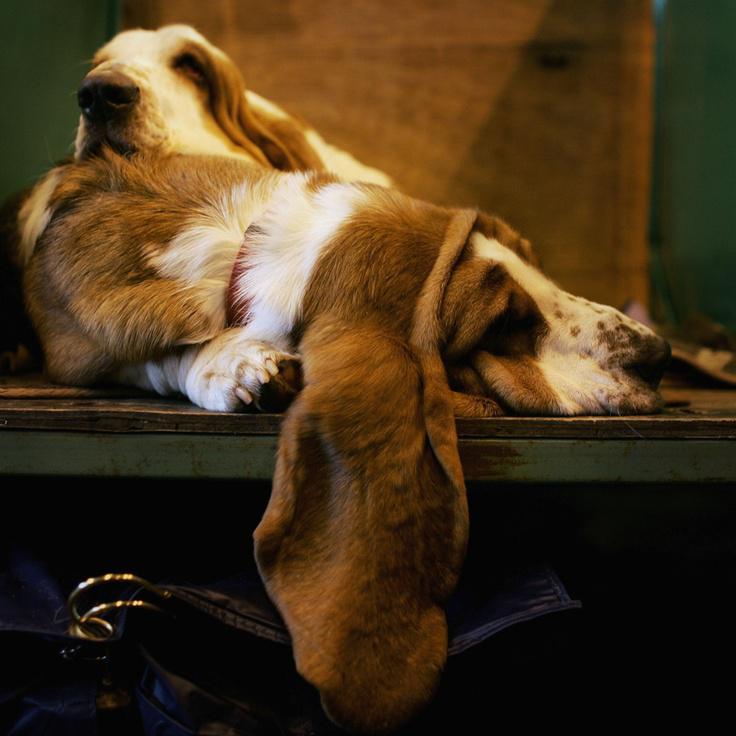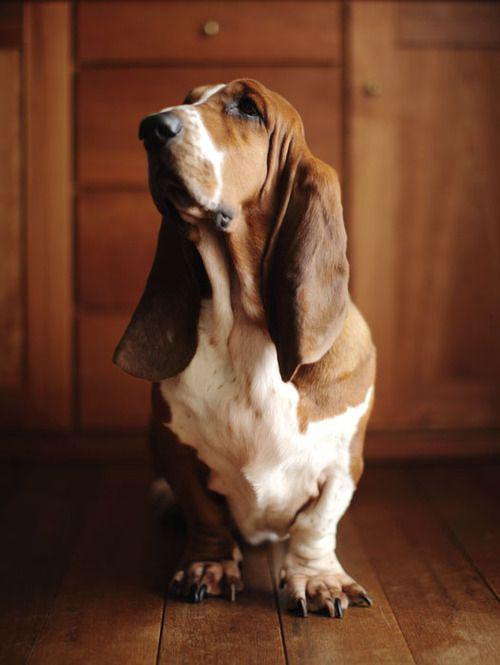The first image is the image on the left, the second image is the image on the right. Given the left and right images, does the statement "A basset hound is sleeping on a platform facing the right, with one ear hanging down." hold true? Answer yes or no. Yes. 